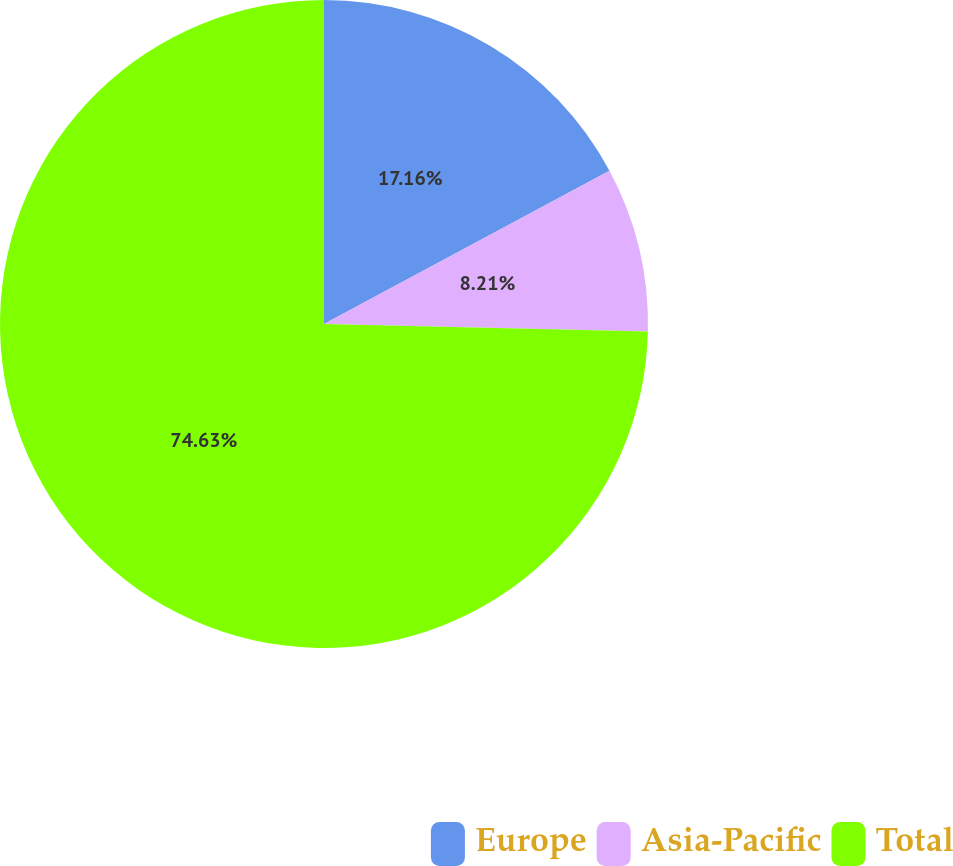Convert chart. <chart><loc_0><loc_0><loc_500><loc_500><pie_chart><fcel>Europe<fcel>Asia-Pacific<fcel>Total<nl><fcel>17.16%<fcel>8.21%<fcel>74.63%<nl></chart> 